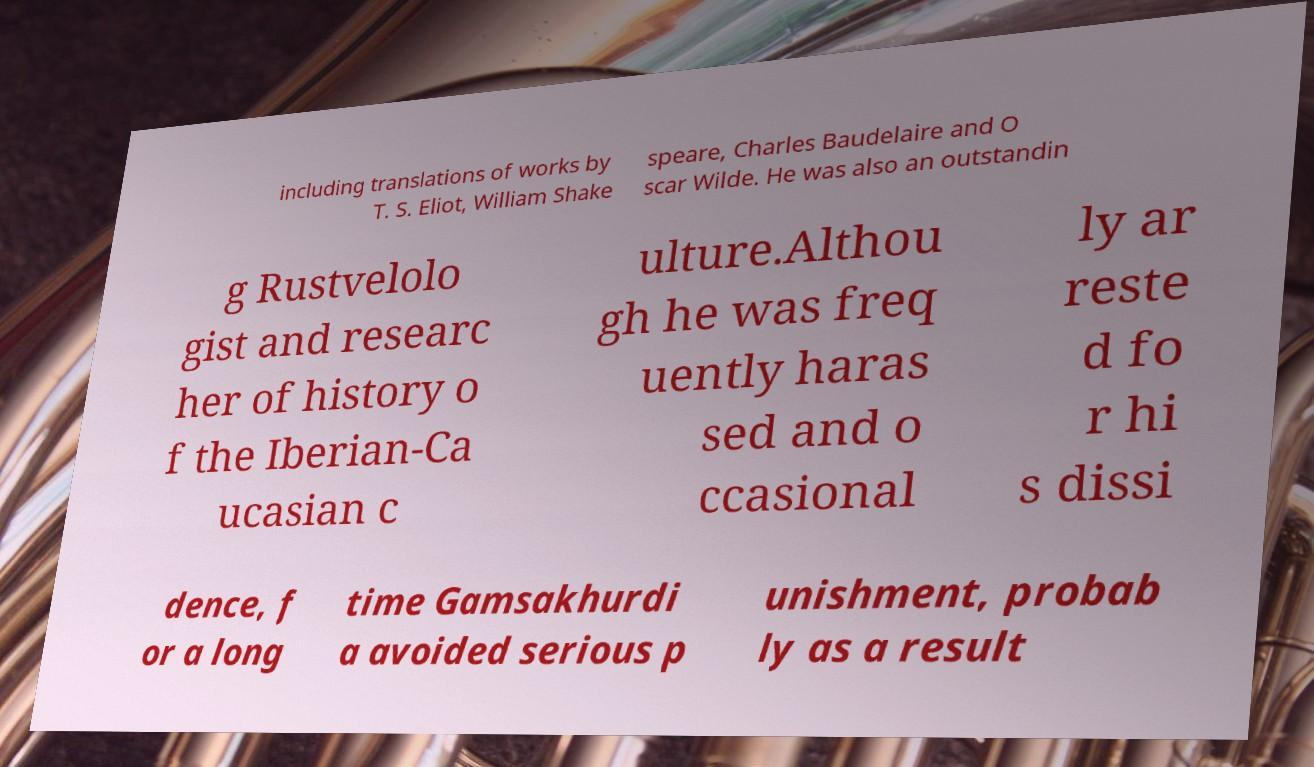Can you accurately transcribe the text from the provided image for me? including translations of works by T. S. Eliot, William Shake speare, Charles Baudelaire and O scar Wilde. He was also an outstandin g Rustvelolo gist and researc her of history o f the Iberian-Ca ucasian c ulture.Althou gh he was freq uently haras sed and o ccasional ly ar reste d fo r hi s dissi dence, f or a long time Gamsakhurdi a avoided serious p unishment, probab ly as a result 